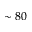Convert formula to latex. <formula><loc_0><loc_0><loc_500><loc_500>\sim 8 0</formula> 